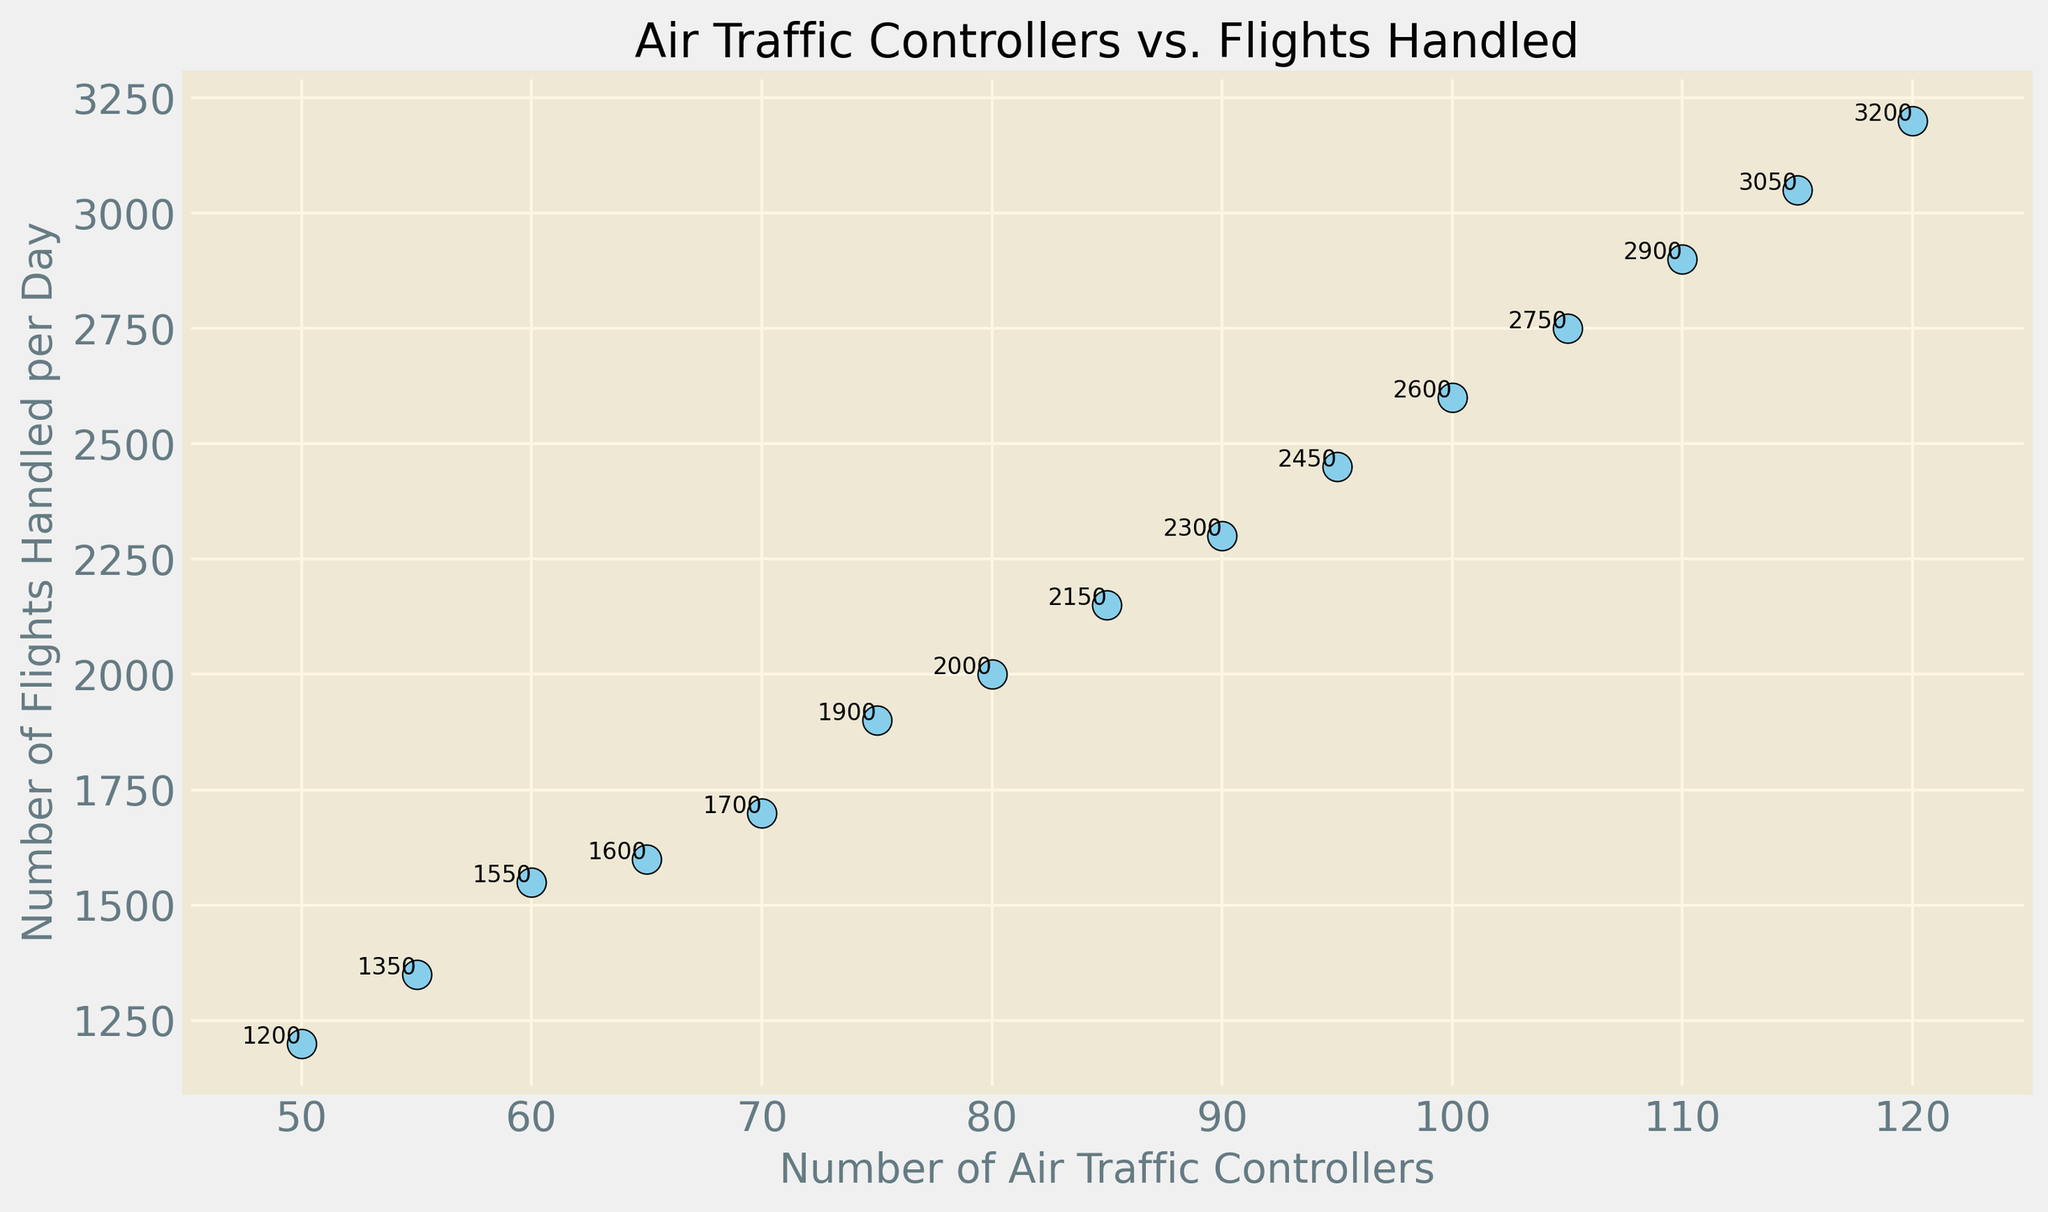What's the trend observed in the scatter plot? The scatter plot shows a positive trend where the number of flights handled per day increases as the number of air traffic controllers increases. This is evident from the upward direction of the points on the graph.
Answer: Positive trend Compare the number of flights handled per day when there are 70 and 90 air traffic controllers. The figure shows that when there are 70 air traffic controllers, approximately 1700 flights are handled per day, and when there are 90 air traffic controllers, approximately 2300 flights are handled per day. Thus, 600 more flights are handled per day with 90 controllers compared to 70 controllers.
Answer: 600 more flights At which number of air traffic controllers does the number of flights handled per day reach 2600? Referring to the plot, we see that the number of flights handled per day reaches 2600 when there are 100 air traffic controllers.
Answer: 100 controllers Which point has the highest number of flights handled per day, and what is that number? The point with the highest number of flights handled per day corresponds to 120 air traffic controllers, handling 3200 flights per day.
Answer: 3200 flights What is the difference in the number of flights handled per day between the lowest and highest number of air traffic controllers in the plot? The lowest number of controllers (50) handles 1200 flights, and the highest number of controllers (120) handles 3200 flights. The difference is 3200 - 1200 = 2000 flights.
Answer: 2000 flights How many flights are handled when there are 75 air traffic controllers, and how does this compare to the flights handled when there are 95 air traffic controllers? When there are 75 air traffic controllers, the plot shows 1900 flights handled per day. When there are 95 air traffic controllers, 2450 flights are handled per day. Thus, 550 more flights are handled with 95 controllers compared to 75 controllers.
Answer: 550 more flights Which number of air traffic controllers is associated with precisely 2000 flights handled per day? According to the plot, precisely 2000 flights are handled per day when there are 80 air traffic controllers.
Answer: 80 controllers What is the average number of flights handled per day for the numbers of air traffic controllers provided in the data? Sum the number of flights handled per day (1200 + 1350 + 1550 + 1600 + 1700 + 1900 + 2000 + 2150 + 2300 + 2450 + 2600 + 2750 + 2900 + 3050 + 3200) and divide by 15. The sum is 37200, so the average is 37200 / 15 = 2480.
Answer: 2480 flights 